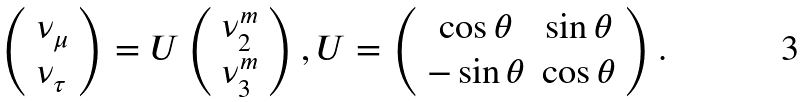Convert formula to latex. <formula><loc_0><loc_0><loc_500><loc_500>\left ( \begin{array} { l } \nu _ { \mu } \\ \nu _ { \tau } \end{array} \right ) = U \left ( \begin{array} { l } \nu _ { 2 } ^ { m } \\ \nu _ { 3 } ^ { m } \end{array} \right ) , U = \left ( \begin{array} { c c } \cos \theta & \sin \theta \\ - \sin \theta & \cos \theta \end{array} \right ) .</formula> 